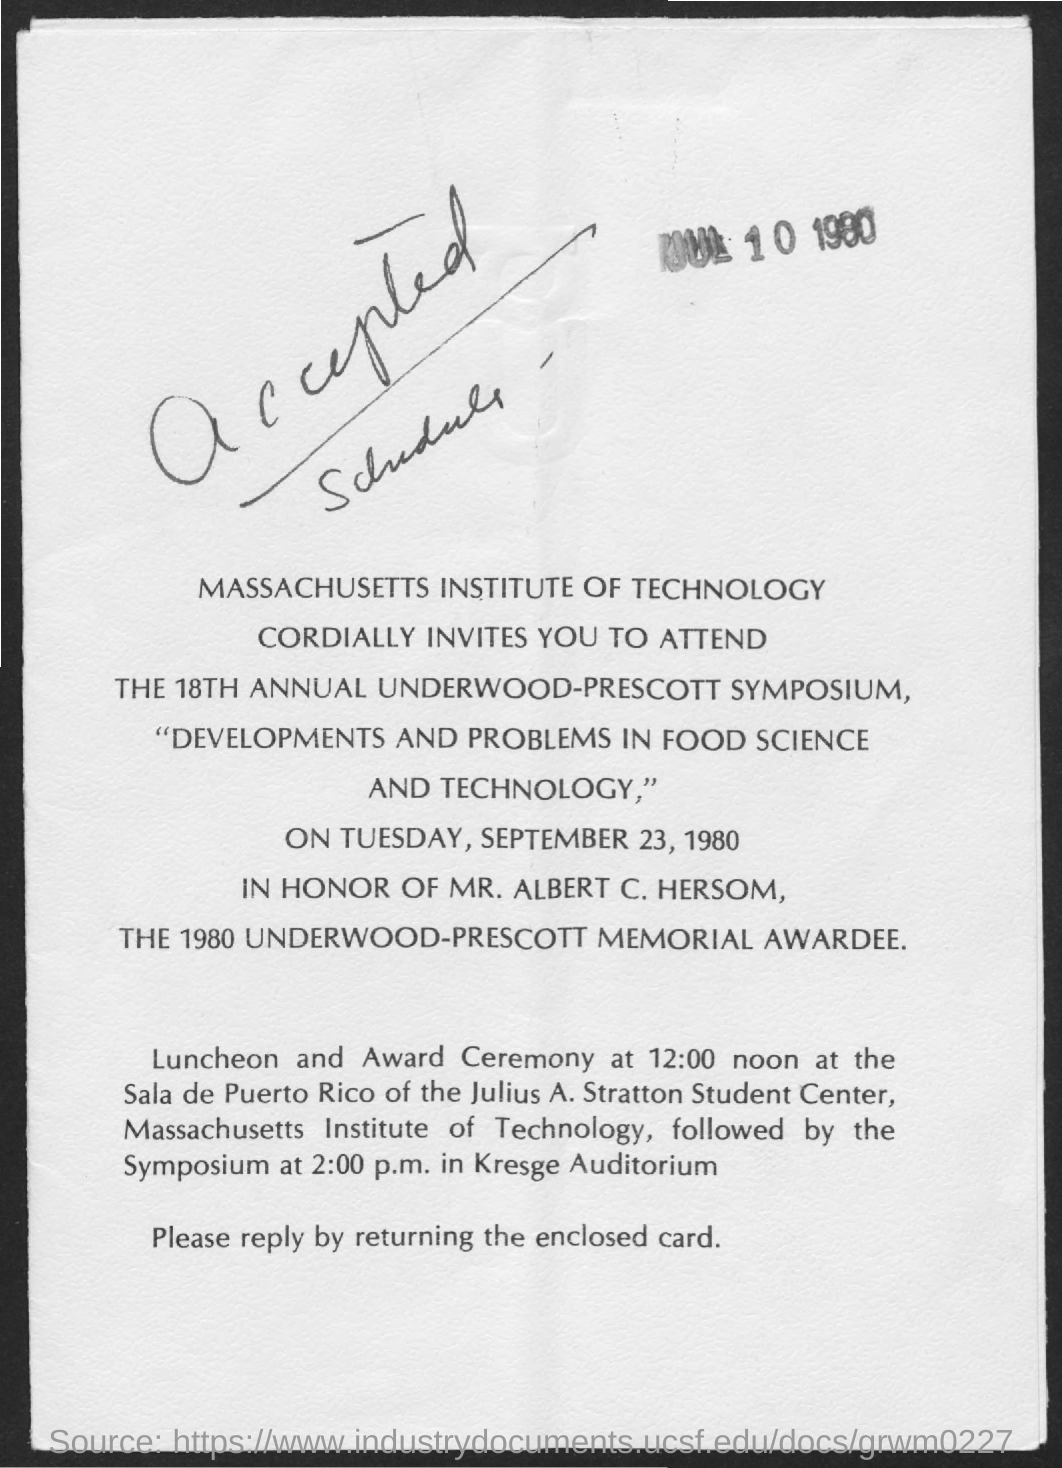At what time luncheon and award ceremony takes place ?
Give a very brief answer. 12:00 noon. What is hand written in the letter
Offer a very short reply. Accepted Schedule. 